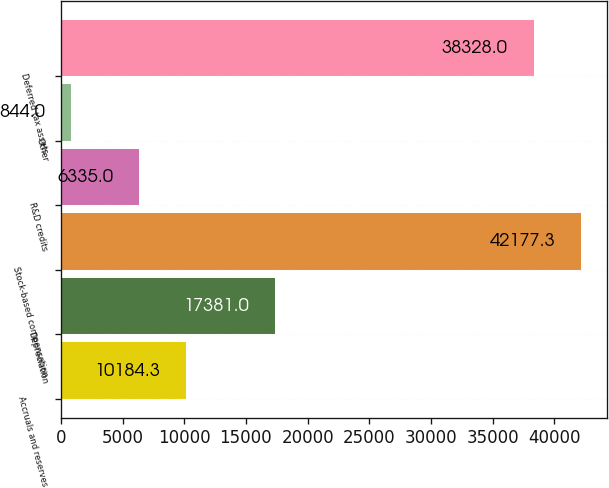<chart> <loc_0><loc_0><loc_500><loc_500><bar_chart><fcel>Accruals and reserves<fcel>Depreciation<fcel>Stock-based compensation<fcel>R&D credits<fcel>Other<fcel>Deferred tax assets<nl><fcel>10184.3<fcel>17381<fcel>42177.3<fcel>6335<fcel>844<fcel>38328<nl></chart> 